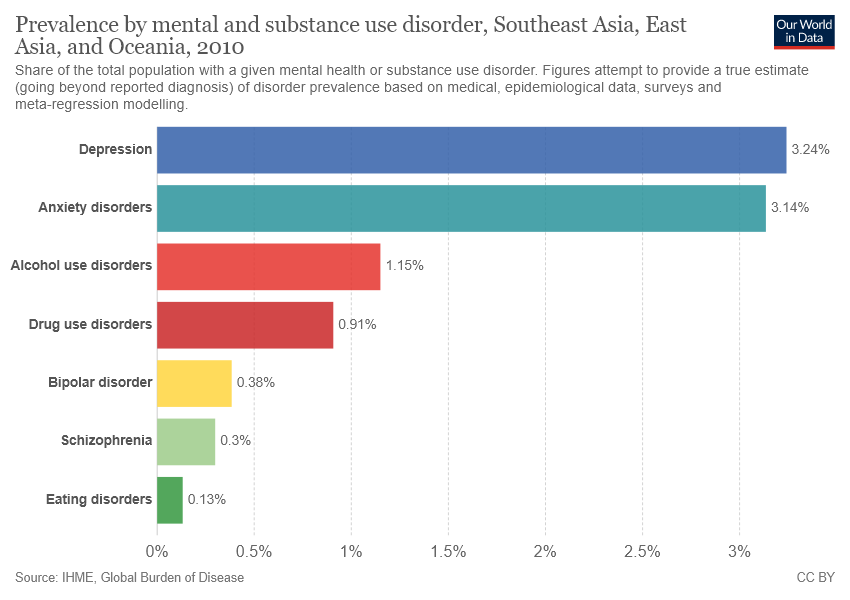Point out several critical features in this image. The sum of eating disorder, schizophrenia, and bipolar disorder values is not greater than that of drug use disorder. The bar graph displays 7 groups of mental health. 